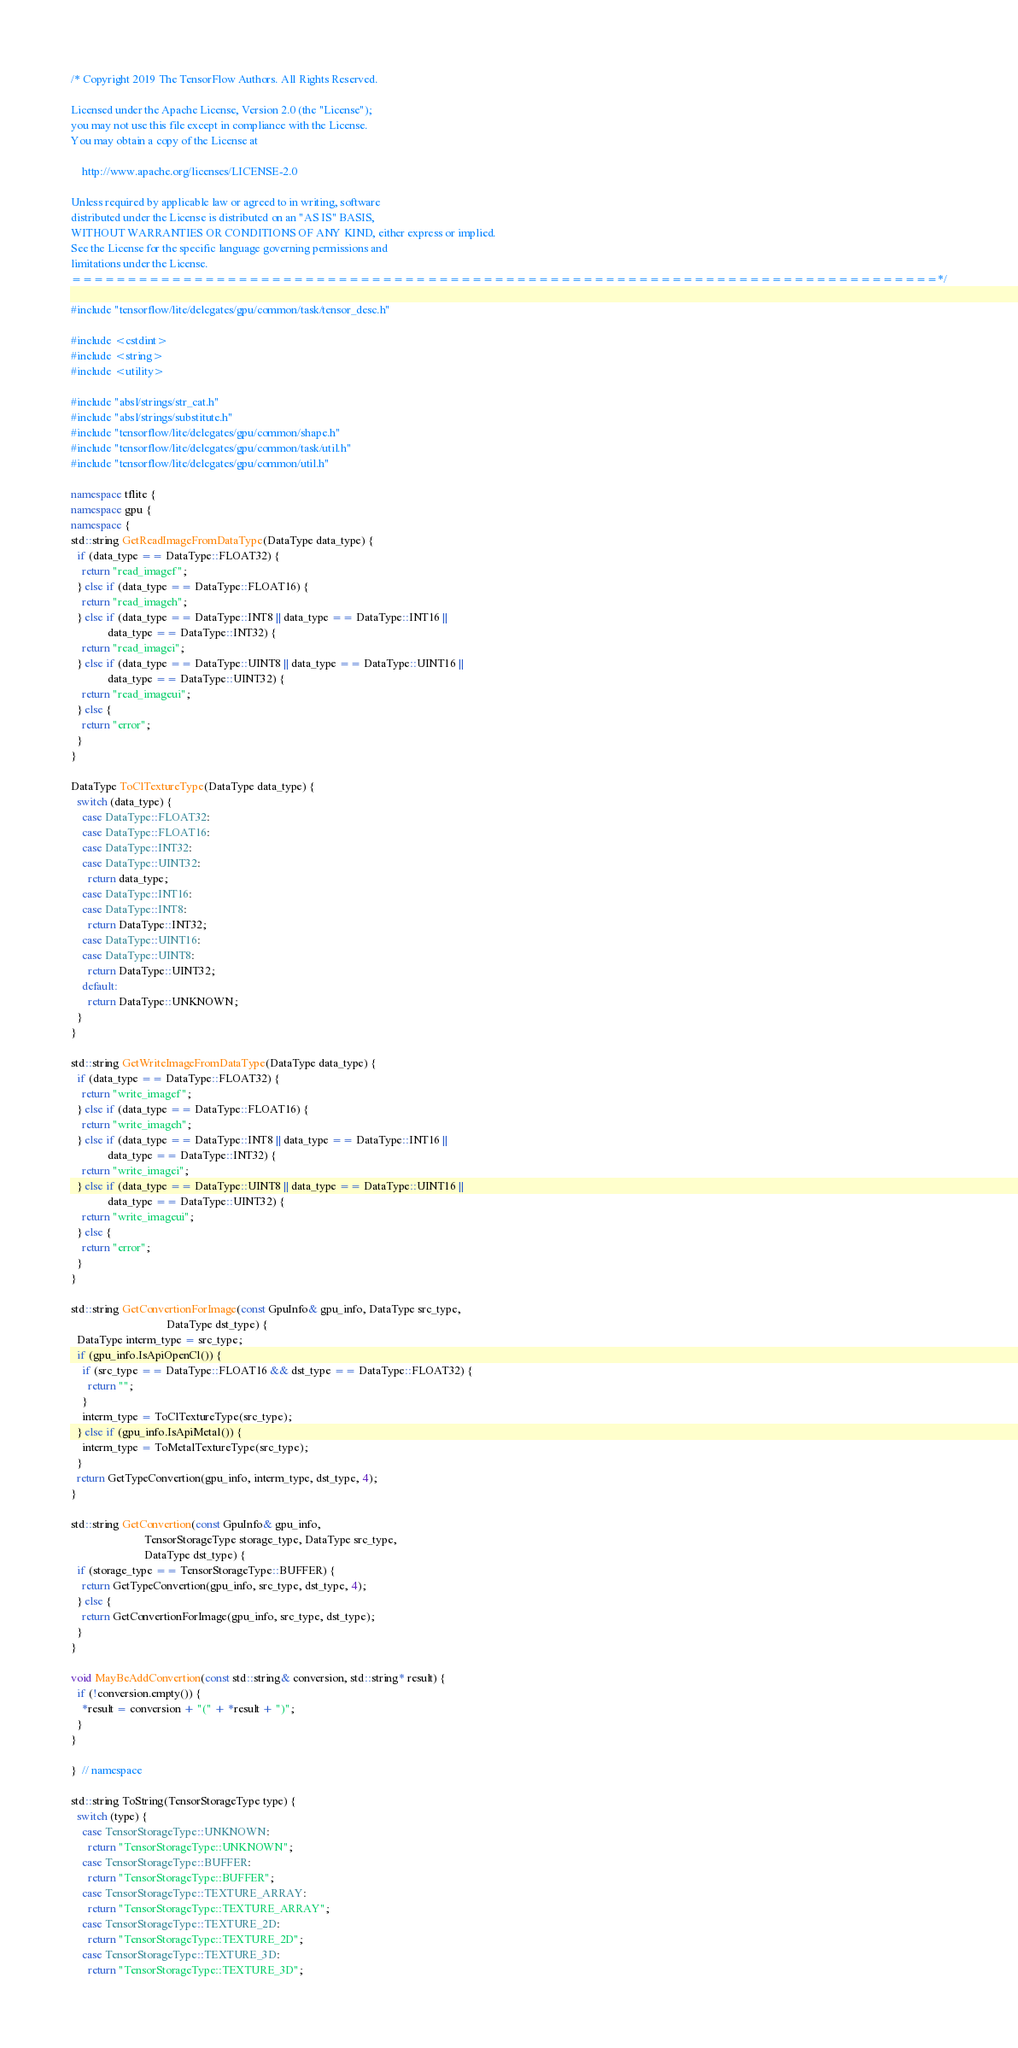Convert code to text. <code><loc_0><loc_0><loc_500><loc_500><_C++_>/* Copyright 2019 The TensorFlow Authors. All Rights Reserved.

Licensed under the Apache License, Version 2.0 (the "License");
you may not use this file except in compliance with the License.
You may obtain a copy of the License at

    http://www.apache.org/licenses/LICENSE-2.0

Unless required by applicable law or agreed to in writing, software
distributed under the License is distributed on an "AS IS" BASIS,
WITHOUT WARRANTIES OR CONDITIONS OF ANY KIND, either express or implied.
See the License for the specific language governing permissions and
limitations under the License.
==============================================================================*/

#include "tensorflow/lite/delegates/gpu/common/task/tensor_desc.h"

#include <cstdint>
#include <string>
#include <utility>

#include "absl/strings/str_cat.h"
#include "absl/strings/substitute.h"
#include "tensorflow/lite/delegates/gpu/common/shape.h"
#include "tensorflow/lite/delegates/gpu/common/task/util.h"
#include "tensorflow/lite/delegates/gpu/common/util.h"

namespace tflite {
namespace gpu {
namespace {
std::string GetReadImageFromDataType(DataType data_type) {
  if (data_type == DataType::FLOAT32) {
    return "read_imagef";
  } else if (data_type == DataType::FLOAT16) {
    return "read_imageh";
  } else if (data_type == DataType::INT8 || data_type == DataType::INT16 ||
             data_type == DataType::INT32) {
    return "read_imagei";
  } else if (data_type == DataType::UINT8 || data_type == DataType::UINT16 ||
             data_type == DataType::UINT32) {
    return "read_imageui";
  } else {
    return "error";
  }
}

DataType ToClTextureType(DataType data_type) {
  switch (data_type) {
    case DataType::FLOAT32:
    case DataType::FLOAT16:
    case DataType::INT32:
    case DataType::UINT32:
      return data_type;
    case DataType::INT16:
    case DataType::INT8:
      return DataType::INT32;
    case DataType::UINT16:
    case DataType::UINT8:
      return DataType::UINT32;
    default:
      return DataType::UNKNOWN;
  }
}

std::string GetWriteImageFromDataType(DataType data_type) {
  if (data_type == DataType::FLOAT32) {
    return "write_imagef";
  } else if (data_type == DataType::FLOAT16) {
    return "write_imageh";
  } else if (data_type == DataType::INT8 || data_type == DataType::INT16 ||
             data_type == DataType::INT32) {
    return "write_imagei";
  } else if (data_type == DataType::UINT8 || data_type == DataType::UINT16 ||
             data_type == DataType::UINT32) {
    return "write_imageui";
  } else {
    return "error";
  }
}

std::string GetConvertionForImage(const GpuInfo& gpu_info, DataType src_type,
                                  DataType dst_type) {
  DataType interm_type = src_type;
  if (gpu_info.IsApiOpenCl()) {
    if (src_type == DataType::FLOAT16 && dst_type == DataType::FLOAT32) {
      return "";
    }
    interm_type = ToClTextureType(src_type);
  } else if (gpu_info.IsApiMetal()) {
    interm_type = ToMetalTextureType(src_type);
  }
  return GetTypeConvertion(gpu_info, interm_type, dst_type, 4);
}

std::string GetConvertion(const GpuInfo& gpu_info,
                          TensorStorageType storage_type, DataType src_type,
                          DataType dst_type) {
  if (storage_type == TensorStorageType::BUFFER) {
    return GetTypeConvertion(gpu_info, src_type, dst_type, 4);
  } else {
    return GetConvertionForImage(gpu_info, src_type, dst_type);
  }
}

void MayBeAddConvertion(const std::string& conversion, std::string* result) {
  if (!conversion.empty()) {
    *result = conversion + "(" + *result + ")";
  }
}

}  // namespace

std::string ToString(TensorStorageType type) {
  switch (type) {
    case TensorStorageType::UNKNOWN:
      return "TensorStorageType::UNKNOWN";
    case TensorStorageType::BUFFER:
      return "TensorStorageType::BUFFER";
    case TensorStorageType::TEXTURE_ARRAY:
      return "TensorStorageType::TEXTURE_ARRAY";
    case TensorStorageType::TEXTURE_2D:
      return "TensorStorageType::TEXTURE_2D";
    case TensorStorageType::TEXTURE_3D:
      return "TensorStorageType::TEXTURE_3D";</code> 